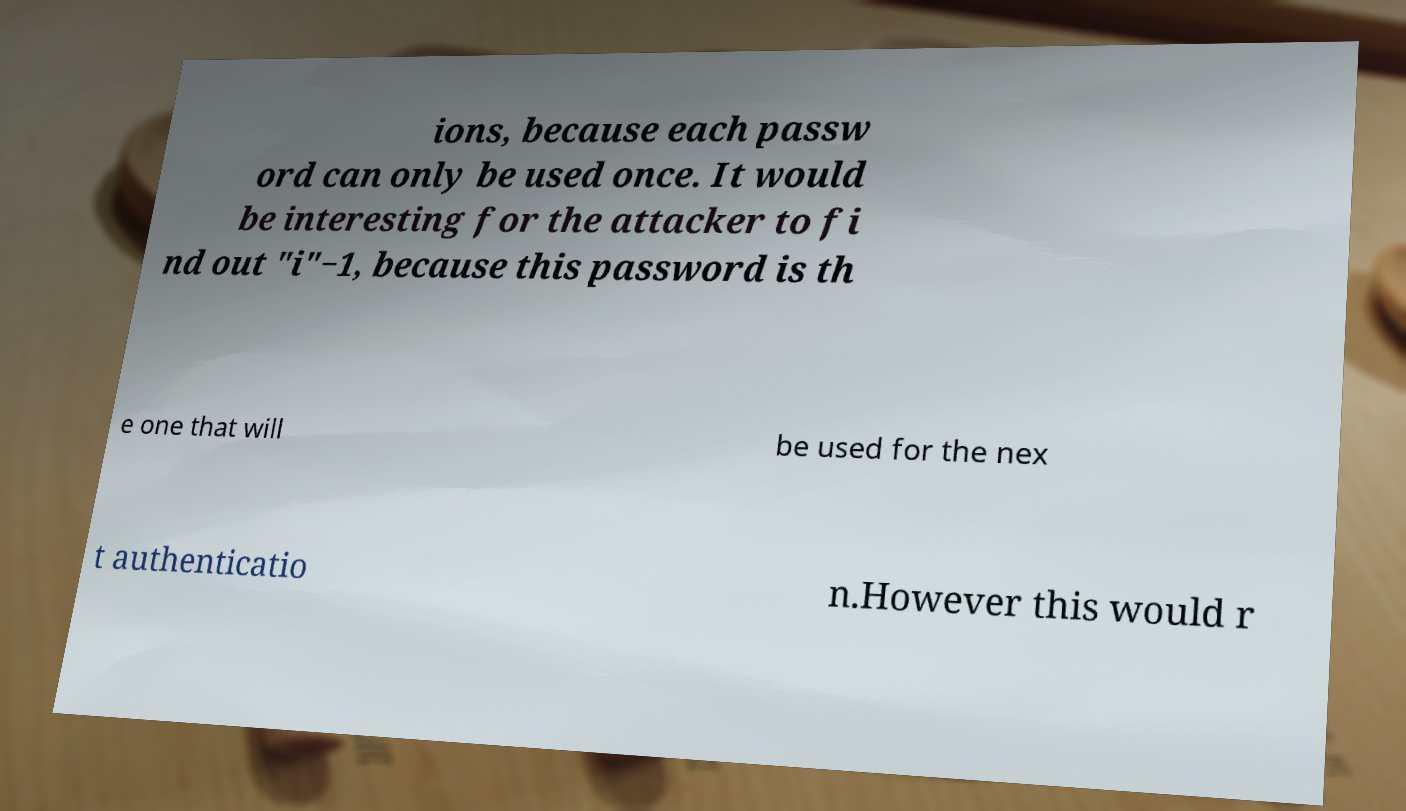Can you accurately transcribe the text from the provided image for me? ions, because each passw ord can only be used once. It would be interesting for the attacker to fi nd out "i"−1, because this password is th e one that will be used for the nex t authenticatio n.However this would r 